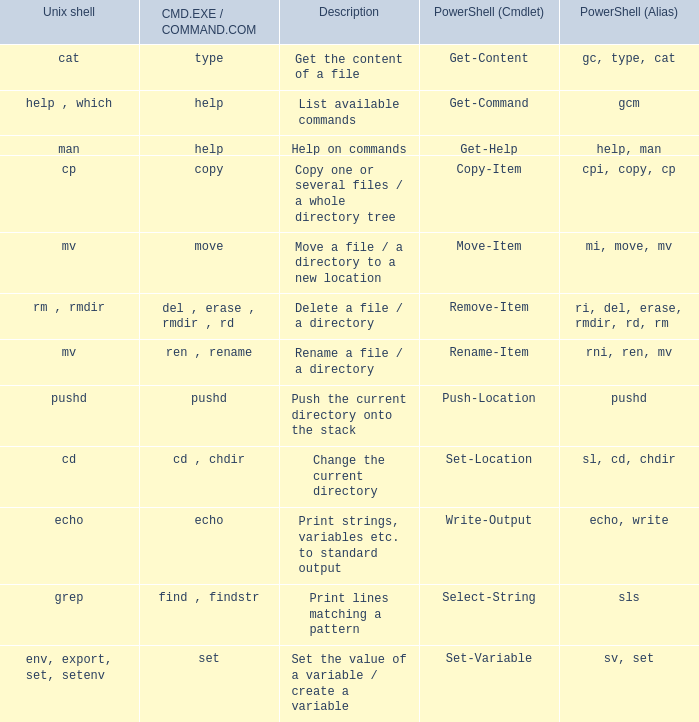What are the names of all unix shell with PowerShell (Cmdlet) of select-string? Grep. 